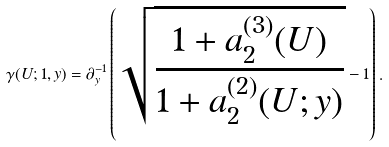Convert formula to latex. <formula><loc_0><loc_0><loc_500><loc_500>\gamma ( U ; 1 , y ) = \partial _ { y } ^ { - 1 } \left ( \sqrt { \frac { 1 + a _ { 2 } ^ { ( 3 ) } ( U ) } { 1 + a ^ { ( 2 ) } _ { 2 } ( U ; y ) } } - 1 \right ) .</formula> 